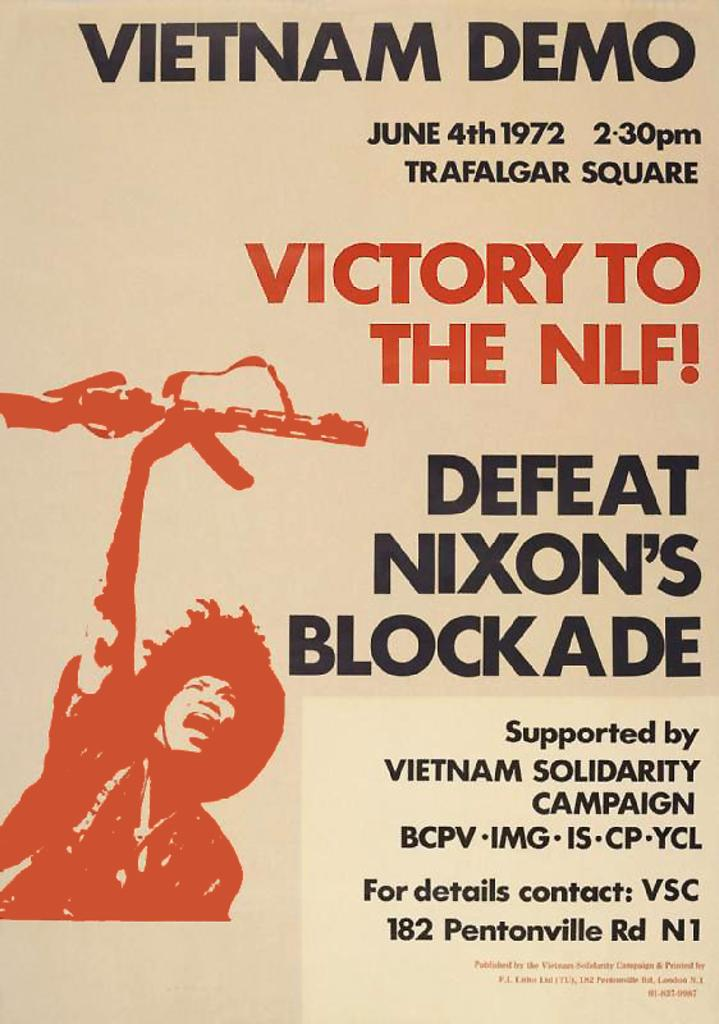Provide a one-sentence caption for the provided image. A poster that is for a demonstration against Nixon in Vietnam. 